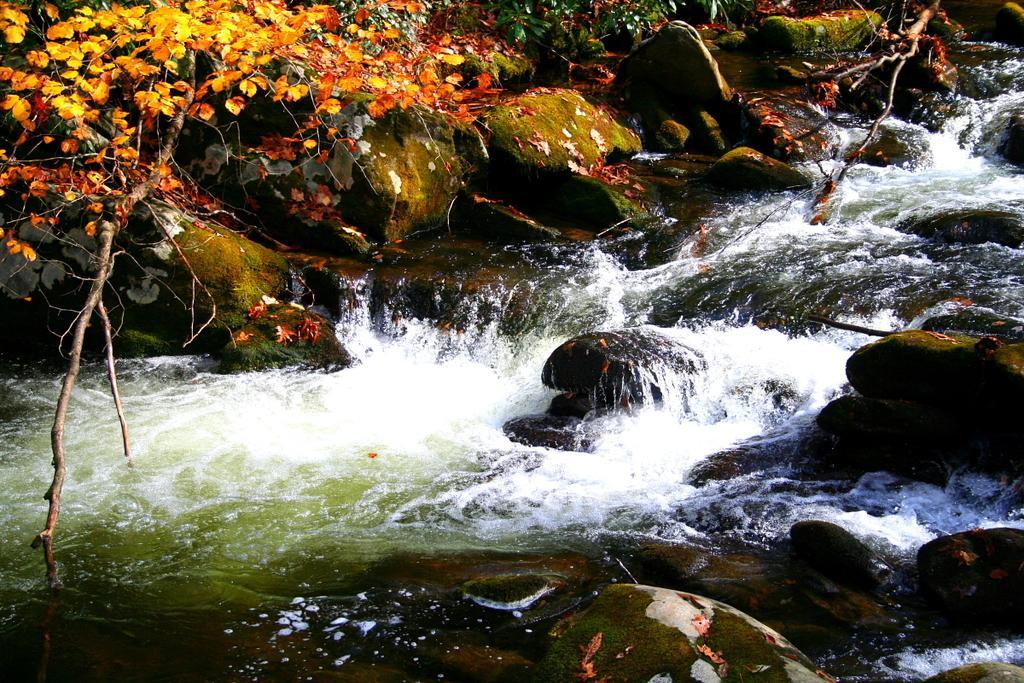Please provide a concise description of this image. In the image we can see the river, stones, leaves and the tree branches. 